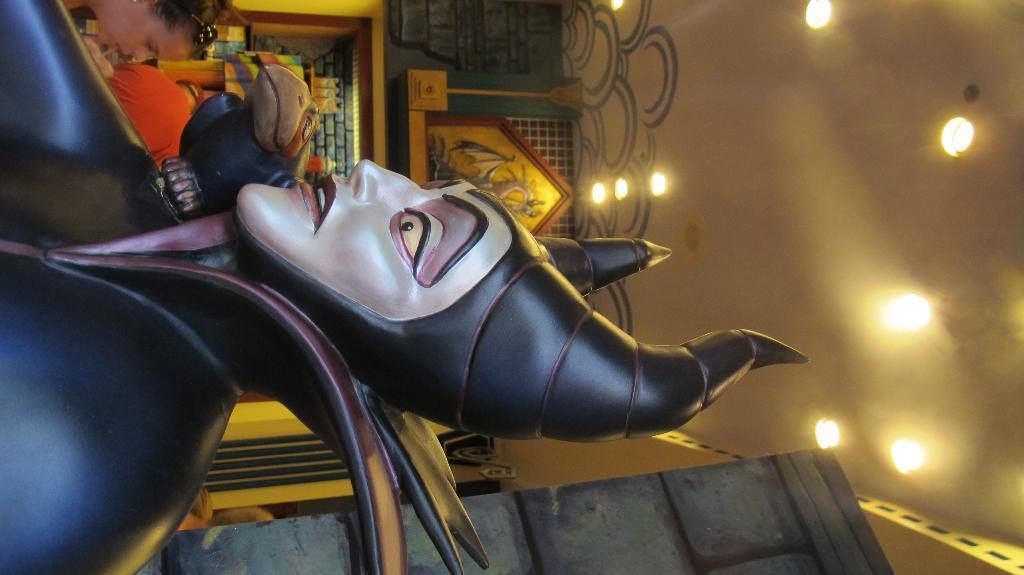What is the main subject in the foreground of the image? There is a sculpture in the foreground of the image. What can be seen in the background of the image? There are people and a wall in the background of the image. Are there any artificial light sources visible in the image? Yes, there are lights on the ceiling in the background of the image. What is located at the bottom of the image? There is an object at the bottom of the image. How does the sea affect the sculpture in the image? There is no sea present in the image, so it cannot affect the sculpture. What type of control system is used to manage the lights in the image? There is no information about a control system for the lights in the image. 